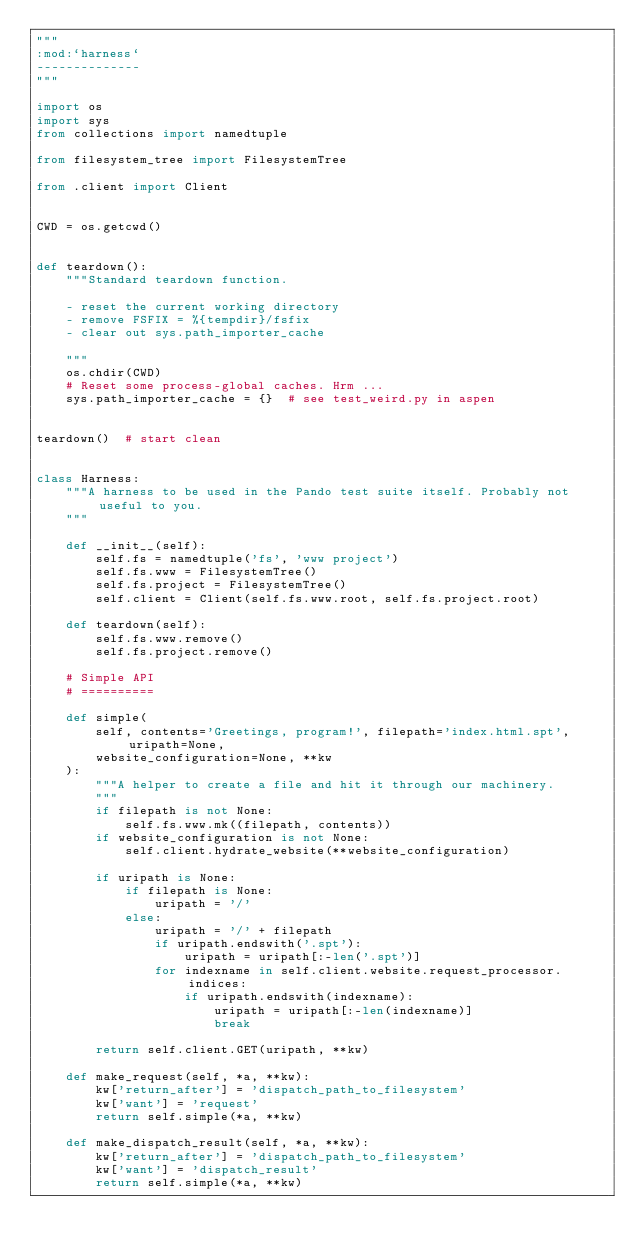<code> <loc_0><loc_0><loc_500><loc_500><_Python_>"""
:mod:`harness`
--------------
"""

import os
import sys
from collections import namedtuple

from filesystem_tree import FilesystemTree

from .client import Client


CWD = os.getcwd()


def teardown():
    """Standard teardown function.

    - reset the current working directory
    - remove FSFIX = %{tempdir}/fsfix
    - clear out sys.path_importer_cache

    """
    os.chdir(CWD)
    # Reset some process-global caches. Hrm ...
    sys.path_importer_cache = {}  # see test_weird.py in aspen


teardown()  # start clean


class Harness:
    """A harness to be used in the Pando test suite itself. Probably not useful to you.
    """

    def __init__(self):
        self.fs = namedtuple('fs', 'www project')
        self.fs.www = FilesystemTree()
        self.fs.project = FilesystemTree()
        self.client = Client(self.fs.www.root, self.fs.project.root)

    def teardown(self):
        self.fs.www.remove()
        self.fs.project.remove()

    # Simple API
    # ==========

    def simple(
        self, contents='Greetings, program!', filepath='index.html.spt', uripath=None,
        website_configuration=None, **kw
    ):
        """A helper to create a file and hit it through our machinery.
        """
        if filepath is not None:
            self.fs.www.mk((filepath, contents))
        if website_configuration is not None:
            self.client.hydrate_website(**website_configuration)

        if uripath is None:
            if filepath is None:
                uripath = '/'
            else:
                uripath = '/' + filepath
                if uripath.endswith('.spt'):
                    uripath = uripath[:-len('.spt')]
                for indexname in self.client.website.request_processor.indices:
                    if uripath.endswith(indexname):
                        uripath = uripath[:-len(indexname)]
                        break

        return self.client.GET(uripath, **kw)

    def make_request(self, *a, **kw):
        kw['return_after'] = 'dispatch_path_to_filesystem'
        kw['want'] = 'request'
        return self.simple(*a, **kw)

    def make_dispatch_result(self, *a, **kw):
        kw['return_after'] = 'dispatch_path_to_filesystem'
        kw['want'] = 'dispatch_result'
        return self.simple(*a, **kw)
</code> 